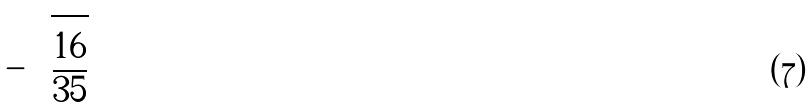<formula> <loc_0><loc_0><loc_500><loc_500>- \sqrt { \frac { 1 6 } { 3 5 } }</formula> 